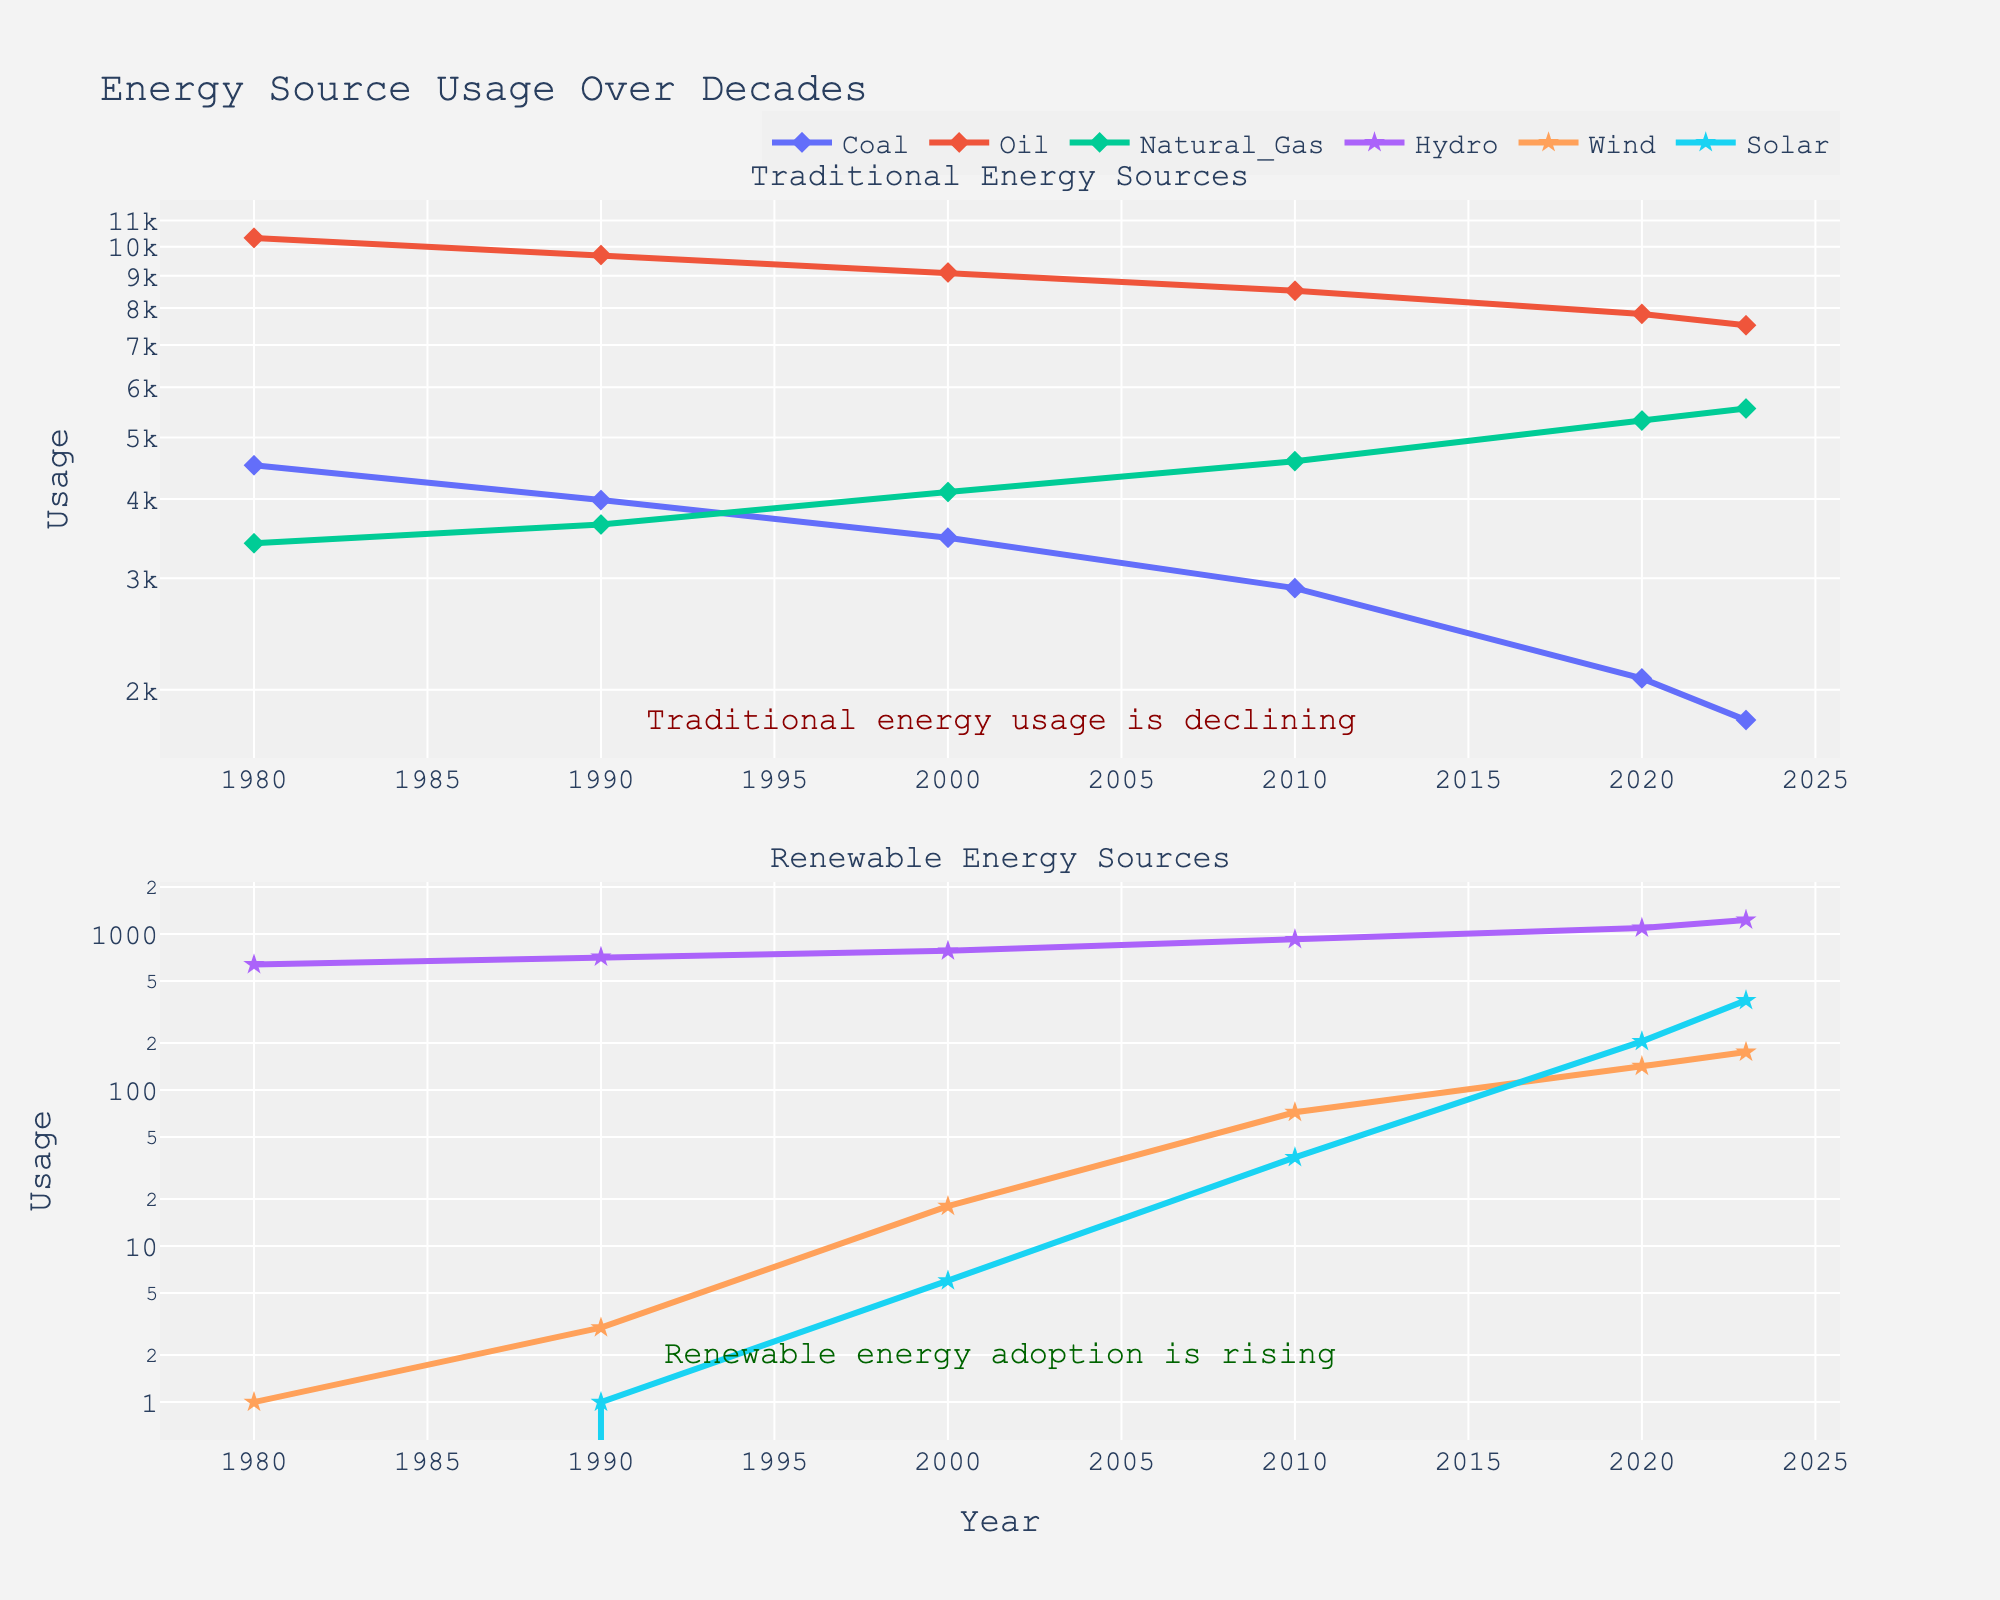What is the title of the figure? The title is usually located at the top of the figure. In this case, it reads "Energy Source Usage Over Decades".
Answer: Energy Source Usage Over Decades What color is used for the background of the plot? The background color can be seen covering the area where the plots are drawn. Here, the background color is light gray.
Answer: Light gray When did Coal usage noticeably begin to decline? Looking at the Coal line in the Traditional Energy Sources subplot, it starts to decline around 1990.
Answer: Around 1990 By how much did Solar energy usage increase from 2000 to 2023? In 2000, Solar usage is 6, and in 2023, it is 375. The increase is calculated as 375 - 6 = 369.
Answer: 369 Which year shows a significant increase in Solar energy usage? The Solar energy line in the Renewable Energy Sources subplot shows a steep rise between 2010 and 2020.
Answer: Between 2010 and 2020 How does the usage of Hydro energy in 1980 compare to its usage in 2020? In 1980, Hydro energy usage is 637, and in 2020 it is 1092. Comparing them, 1092 is higher than 637.
Answer: Higher in 2020 Which traditional energy source experienced the highest usage decline between 1980 and 2023? By checking the slopes in the Traditional Energy Sources subplot, Coal shows the steepest decline from 4523 in 1980 to 1792 in 2023.
Answer: Coal What trend is seen in the usage of Natural Gas over the decades? Observing the Natural Gas line in the Traditional Energy Sources subplot, it shows a steady increase from 3405 in 1980 to 5555 in 2023.
Answer: Steady increase Which renewable energy source had the least usage in 1990? In the Renewable Energy Sources subplot, Wind and Solar are very low in 1990, but Solar is the least with a usage of 1.
Answer: Solar How does the usage of Oil in 2023 compare to its usage in 1980? The Oil line in the Traditional Energy Sources subplot shows a decline from 10324 in 1980 to 7520 in 2023.
Answer: Decreased 